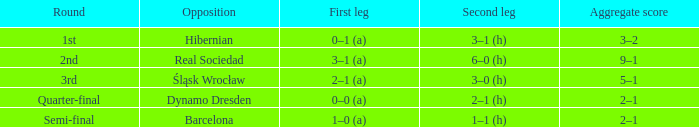What was the first leg against Hibernian? 0–1 (a). 